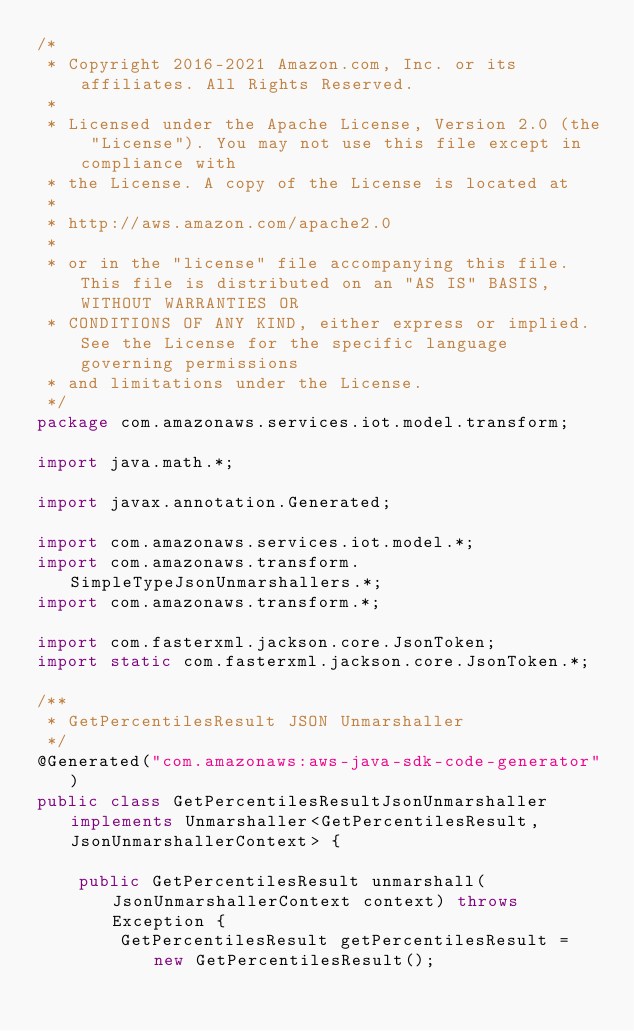<code> <loc_0><loc_0><loc_500><loc_500><_Java_>/*
 * Copyright 2016-2021 Amazon.com, Inc. or its affiliates. All Rights Reserved.
 * 
 * Licensed under the Apache License, Version 2.0 (the "License"). You may not use this file except in compliance with
 * the License. A copy of the License is located at
 * 
 * http://aws.amazon.com/apache2.0
 * 
 * or in the "license" file accompanying this file. This file is distributed on an "AS IS" BASIS, WITHOUT WARRANTIES OR
 * CONDITIONS OF ANY KIND, either express or implied. See the License for the specific language governing permissions
 * and limitations under the License.
 */
package com.amazonaws.services.iot.model.transform;

import java.math.*;

import javax.annotation.Generated;

import com.amazonaws.services.iot.model.*;
import com.amazonaws.transform.SimpleTypeJsonUnmarshallers.*;
import com.amazonaws.transform.*;

import com.fasterxml.jackson.core.JsonToken;
import static com.fasterxml.jackson.core.JsonToken.*;

/**
 * GetPercentilesResult JSON Unmarshaller
 */
@Generated("com.amazonaws:aws-java-sdk-code-generator")
public class GetPercentilesResultJsonUnmarshaller implements Unmarshaller<GetPercentilesResult, JsonUnmarshallerContext> {

    public GetPercentilesResult unmarshall(JsonUnmarshallerContext context) throws Exception {
        GetPercentilesResult getPercentilesResult = new GetPercentilesResult();
</code> 